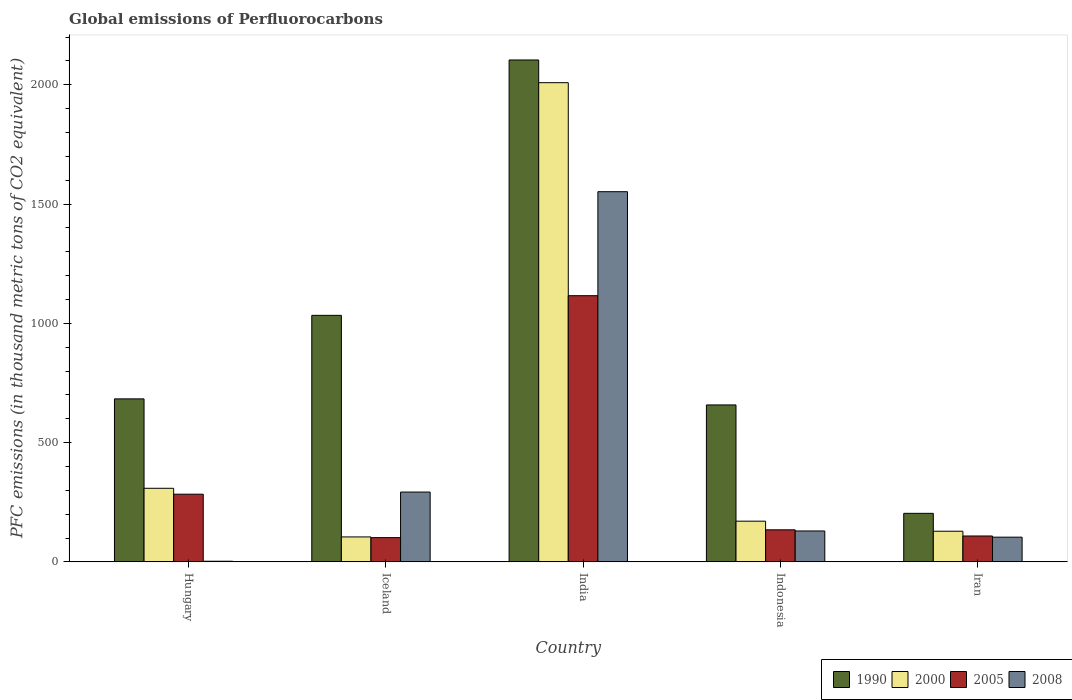How many different coloured bars are there?
Provide a succinct answer. 4. What is the global emissions of Perfluorocarbons in 2000 in Indonesia?
Your response must be concise. 170.6. Across all countries, what is the maximum global emissions of Perfluorocarbons in 1990?
Provide a succinct answer. 2104. In which country was the global emissions of Perfluorocarbons in 2008 minimum?
Offer a terse response. Hungary. What is the total global emissions of Perfluorocarbons in 2000 in the graph?
Offer a terse response. 2721. What is the difference between the global emissions of Perfluorocarbons in 2000 in India and that in Indonesia?
Give a very brief answer. 1838.2. What is the difference between the global emissions of Perfluorocarbons in 2000 in Iran and the global emissions of Perfluorocarbons in 2008 in Hungary?
Keep it short and to the point. 125.8. What is the average global emissions of Perfluorocarbons in 2008 per country?
Your answer should be compact. 416.08. What is the ratio of the global emissions of Perfluorocarbons in 2008 in India to that in Iran?
Keep it short and to the point. 14.98. Is the difference between the global emissions of Perfluorocarbons in 2005 in India and Iran greater than the difference between the global emissions of Perfluorocarbons in 2000 in India and Iran?
Provide a succinct answer. No. What is the difference between the highest and the second highest global emissions of Perfluorocarbons in 2000?
Offer a very short reply. 1838.2. What is the difference between the highest and the lowest global emissions of Perfluorocarbons in 2008?
Your response must be concise. 1549.1. Is the sum of the global emissions of Perfluorocarbons in 2008 in India and Iran greater than the maximum global emissions of Perfluorocarbons in 1990 across all countries?
Give a very brief answer. No. What does the 4th bar from the left in Iceland represents?
Your answer should be very brief. 2008. What does the 2nd bar from the right in Iceland represents?
Make the answer very short. 2005. How many bars are there?
Make the answer very short. 20. Are the values on the major ticks of Y-axis written in scientific E-notation?
Keep it short and to the point. No. Does the graph contain any zero values?
Make the answer very short. No. Does the graph contain grids?
Your response must be concise. No. Where does the legend appear in the graph?
Offer a terse response. Bottom right. What is the title of the graph?
Offer a terse response. Global emissions of Perfluorocarbons. What is the label or title of the Y-axis?
Offer a very short reply. PFC emissions (in thousand metric tons of CO2 equivalent). What is the PFC emissions (in thousand metric tons of CO2 equivalent) of 1990 in Hungary?
Ensure brevity in your answer.  683.3. What is the PFC emissions (in thousand metric tons of CO2 equivalent) of 2000 in Hungary?
Give a very brief answer. 308.5. What is the PFC emissions (in thousand metric tons of CO2 equivalent) of 2005 in Hungary?
Your answer should be compact. 283.7. What is the PFC emissions (in thousand metric tons of CO2 equivalent) of 2008 in Hungary?
Provide a short and direct response. 2.7. What is the PFC emissions (in thousand metric tons of CO2 equivalent) of 1990 in Iceland?
Provide a short and direct response. 1033.4. What is the PFC emissions (in thousand metric tons of CO2 equivalent) in 2000 in Iceland?
Keep it short and to the point. 104.6. What is the PFC emissions (in thousand metric tons of CO2 equivalent) of 2005 in Iceland?
Make the answer very short. 101.6. What is the PFC emissions (in thousand metric tons of CO2 equivalent) of 2008 in Iceland?
Offer a terse response. 292.7. What is the PFC emissions (in thousand metric tons of CO2 equivalent) of 1990 in India?
Your answer should be compact. 2104. What is the PFC emissions (in thousand metric tons of CO2 equivalent) in 2000 in India?
Your answer should be compact. 2008.8. What is the PFC emissions (in thousand metric tons of CO2 equivalent) of 2005 in India?
Your answer should be very brief. 1115.8. What is the PFC emissions (in thousand metric tons of CO2 equivalent) in 2008 in India?
Ensure brevity in your answer.  1551.8. What is the PFC emissions (in thousand metric tons of CO2 equivalent) of 1990 in Indonesia?
Make the answer very short. 657.9. What is the PFC emissions (in thousand metric tons of CO2 equivalent) in 2000 in Indonesia?
Make the answer very short. 170.6. What is the PFC emissions (in thousand metric tons of CO2 equivalent) in 2005 in Indonesia?
Make the answer very short. 134.4. What is the PFC emissions (in thousand metric tons of CO2 equivalent) in 2008 in Indonesia?
Give a very brief answer. 129.6. What is the PFC emissions (in thousand metric tons of CO2 equivalent) in 1990 in Iran?
Your response must be concise. 203.5. What is the PFC emissions (in thousand metric tons of CO2 equivalent) in 2000 in Iran?
Keep it short and to the point. 128.5. What is the PFC emissions (in thousand metric tons of CO2 equivalent) in 2005 in Iran?
Offer a terse response. 108.5. What is the PFC emissions (in thousand metric tons of CO2 equivalent) in 2008 in Iran?
Give a very brief answer. 103.6. Across all countries, what is the maximum PFC emissions (in thousand metric tons of CO2 equivalent) of 1990?
Make the answer very short. 2104. Across all countries, what is the maximum PFC emissions (in thousand metric tons of CO2 equivalent) of 2000?
Your answer should be very brief. 2008.8. Across all countries, what is the maximum PFC emissions (in thousand metric tons of CO2 equivalent) in 2005?
Your answer should be compact. 1115.8. Across all countries, what is the maximum PFC emissions (in thousand metric tons of CO2 equivalent) of 2008?
Offer a terse response. 1551.8. Across all countries, what is the minimum PFC emissions (in thousand metric tons of CO2 equivalent) of 1990?
Make the answer very short. 203.5. Across all countries, what is the minimum PFC emissions (in thousand metric tons of CO2 equivalent) of 2000?
Keep it short and to the point. 104.6. Across all countries, what is the minimum PFC emissions (in thousand metric tons of CO2 equivalent) in 2005?
Your answer should be compact. 101.6. Across all countries, what is the minimum PFC emissions (in thousand metric tons of CO2 equivalent) in 2008?
Make the answer very short. 2.7. What is the total PFC emissions (in thousand metric tons of CO2 equivalent) of 1990 in the graph?
Offer a very short reply. 4682.1. What is the total PFC emissions (in thousand metric tons of CO2 equivalent) of 2000 in the graph?
Ensure brevity in your answer.  2721. What is the total PFC emissions (in thousand metric tons of CO2 equivalent) in 2005 in the graph?
Your answer should be compact. 1744. What is the total PFC emissions (in thousand metric tons of CO2 equivalent) of 2008 in the graph?
Give a very brief answer. 2080.4. What is the difference between the PFC emissions (in thousand metric tons of CO2 equivalent) of 1990 in Hungary and that in Iceland?
Keep it short and to the point. -350.1. What is the difference between the PFC emissions (in thousand metric tons of CO2 equivalent) in 2000 in Hungary and that in Iceland?
Offer a very short reply. 203.9. What is the difference between the PFC emissions (in thousand metric tons of CO2 equivalent) of 2005 in Hungary and that in Iceland?
Give a very brief answer. 182.1. What is the difference between the PFC emissions (in thousand metric tons of CO2 equivalent) of 2008 in Hungary and that in Iceland?
Make the answer very short. -290. What is the difference between the PFC emissions (in thousand metric tons of CO2 equivalent) in 1990 in Hungary and that in India?
Provide a short and direct response. -1420.7. What is the difference between the PFC emissions (in thousand metric tons of CO2 equivalent) in 2000 in Hungary and that in India?
Offer a terse response. -1700.3. What is the difference between the PFC emissions (in thousand metric tons of CO2 equivalent) in 2005 in Hungary and that in India?
Ensure brevity in your answer.  -832.1. What is the difference between the PFC emissions (in thousand metric tons of CO2 equivalent) in 2008 in Hungary and that in India?
Make the answer very short. -1549.1. What is the difference between the PFC emissions (in thousand metric tons of CO2 equivalent) of 1990 in Hungary and that in Indonesia?
Provide a succinct answer. 25.4. What is the difference between the PFC emissions (in thousand metric tons of CO2 equivalent) in 2000 in Hungary and that in Indonesia?
Your answer should be compact. 137.9. What is the difference between the PFC emissions (in thousand metric tons of CO2 equivalent) of 2005 in Hungary and that in Indonesia?
Ensure brevity in your answer.  149.3. What is the difference between the PFC emissions (in thousand metric tons of CO2 equivalent) in 2008 in Hungary and that in Indonesia?
Make the answer very short. -126.9. What is the difference between the PFC emissions (in thousand metric tons of CO2 equivalent) in 1990 in Hungary and that in Iran?
Keep it short and to the point. 479.8. What is the difference between the PFC emissions (in thousand metric tons of CO2 equivalent) in 2000 in Hungary and that in Iran?
Your answer should be very brief. 180. What is the difference between the PFC emissions (in thousand metric tons of CO2 equivalent) in 2005 in Hungary and that in Iran?
Offer a terse response. 175.2. What is the difference between the PFC emissions (in thousand metric tons of CO2 equivalent) in 2008 in Hungary and that in Iran?
Provide a short and direct response. -100.9. What is the difference between the PFC emissions (in thousand metric tons of CO2 equivalent) in 1990 in Iceland and that in India?
Your answer should be very brief. -1070.6. What is the difference between the PFC emissions (in thousand metric tons of CO2 equivalent) in 2000 in Iceland and that in India?
Your response must be concise. -1904.2. What is the difference between the PFC emissions (in thousand metric tons of CO2 equivalent) of 2005 in Iceland and that in India?
Ensure brevity in your answer.  -1014.2. What is the difference between the PFC emissions (in thousand metric tons of CO2 equivalent) in 2008 in Iceland and that in India?
Your response must be concise. -1259.1. What is the difference between the PFC emissions (in thousand metric tons of CO2 equivalent) in 1990 in Iceland and that in Indonesia?
Offer a terse response. 375.5. What is the difference between the PFC emissions (in thousand metric tons of CO2 equivalent) in 2000 in Iceland and that in Indonesia?
Provide a succinct answer. -66. What is the difference between the PFC emissions (in thousand metric tons of CO2 equivalent) of 2005 in Iceland and that in Indonesia?
Offer a terse response. -32.8. What is the difference between the PFC emissions (in thousand metric tons of CO2 equivalent) in 2008 in Iceland and that in Indonesia?
Provide a succinct answer. 163.1. What is the difference between the PFC emissions (in thousand metric tons of CO2 equivalent) of 1990 in Iceland and that in Iran?
Your answer should be very brief. 829.9. What is the difference between the PFC emissions (in thousand metric tons of CO2 equivalent) of 2000 in Iceland and that in Iran?
Your answer should be compact. -23.9. What is the difference between the PFC emissions (in thousand metric tons of CO2 equivalent) of 2008 in Iceland and that in Iran?
Provide a succinct answer. 189.1. What is the difference between the PFC emissions (in thousand metric tons of CO2 equivalent) of 1990 in India and that in Indonesia?
Keep it short and to the point. 1446.1. What is the difference between the PFC emissions (in thousand metric tons of CO2 equivalent) of 2000 in India and that in Indonesia?
Provide a succinct answer. 1838.2. What is the difference between the PFC emissions (in thousand metric tons of CO2 equivalent) in 2005 in India and that in Indonesia?
Your answer should be very brief. 981.4. What is the difference between the PFC emissions (in thousand metric tons of CO2 equivalent) in 2008 in India and that in Indonesia?
Make the answer very short. 1422.2. What is the difference between the PFC emissions (in thousand metric tons of CO2 equivalent) in 1990 in India and that in Iran?
Keep it short and to the point. 1900.5. What is the difference between the PFC emissions (in thousand metric tons of CO2 equivalent) in 2000 in India and that in Iran?
Provide a succinct answer. 1880.3. What is the difference between the PFC emissions (in thousand metric tons of CO2 equivalent) of 2005 in India and that in Iran?
Your answer should be very brief. 1007.3. What is the difference between the PFC emissions (in thousand metric tons of CO2 equivalent) of 2008 in India and that in Iran?
Your answer should be compact. 1448.2. What is the difference between the PFC emissions (in thousand metric tons of CO2 equivalent) in 1990 in Indonesia and that in Iran?
Provide a short and direct response. 454.4. What is the difference between the PFC emissions (in thousand metric tons of CO2 equivalent) in 2000 in Indonesia and that in Iran?
Your answer should be very brief. 42.1. What is the difference between the PFC emissions (in thousand metric tons of CO2 equivalent) in 2005 in Indonesia and that in Iran?
Your answer should be very brief. 25.9. What is the difference between the PFC emissions (in thousand metric tons of CO2 equivalent) in 1990 in Hungary and the PFC emissions (in thousand metric tons of CO2 equivalent) in 2000 in Iceland?
Provide a succinct answer. 578.7. What is the difference between the PFC emissions (in thousand metric tons of CO2 equivalent) of 1990 in Hungary and the PFC emissions (in thousand metric tons of CO2 equivalent) of 2005 in Iceland?
Provide a succinct answer. 581.7. What is the difference between the PFC emissions (in thousand metric tons of CO2 equivalent) of 1990 in Hungary and the PFC emissions (in thousand metric tons of CO2 equivalent) of 2008 in Iceland?
Offer a very short reply. 390.6. What is the difference between the PFC emissions (in thousand metric tons of CO2 equivalent) in 2000 in Hungary and the PFC emissions (in thousand metric tons of CO2 equivalent) in 2005 in Iceland?
Your answer should be compact. 206.9. What is the difference between the PFC emissions (in thousand metric tons of CO2 equivalent) of 2000 in Hungary and the PFC emissions (in thousand metric tons of CO2 equivalent) of 2008 in Iceland?
Offer a very short reply. 15.8. What is the difference between the PFC emissions (in thousand metric tons of CO2 equivalent) of 2005 in Hungary and the PFC emissions (in thousand metric tons of CO2 equivalent) of 2008 in Iceland?
Provide a succinct answer. -9. What is the difference between the PFC emissions (in thousand metric tons of CO2 equivalent) in 1990 in Hungary and the PFC emissions (in thousand metric tons of CO2 equivalent) in 2000 in India?
Provide a short and direct response. -1325.5. What is the difference between the PFC emissions (in thousand metric tons of CO2 equivalent) of 1990 in Hungary and the PFC emissions (in thousand metric tons of CO2 equivalent) of 2005 in India?
Provide a succinct answer. -432.5. What is the difference between the PFC emissions (in thousand metric tons of CO2 equivalent) in 1990 in Hungary and the PFC emissions (in thousand metric tons of CO2 equivalent) in 2008 in India?
Provide a short and direct response. -868.5. What is the difference between the PFC emissions (in thousand metric tons of CO2 equivalent) in 2000 in Hungary and the PFC emissions (in thousand metric tons of CO2 equivalent) in 2005 in India?
Your answer should be compact. -807.3. What is the difference between the PFC emissions (in thousand metric tons of CO2 equivalent) of 2000 in Hungary and the PFC emissions (in thousand metric tons of CO2 equivalent) of 2008 in India?
Your response must be concise. -1243.3. What is the difference between the PFC emissions (in thousand metric tons of CO2 equivalent) of 2005 in Hungary and the PFC emissions (in thousand metric tons of CO2 equivalent) of 2008 in India?
Your answer should be compact. -1268.1. What is the difference between the PFC emissions (in thousand metric tons of CO2 equivalent) in 1990 in Hungary and the PFC emissions (in thousand metric tons of CO2 equivalent) in 2000 in Indonesia?
Your response must be concise. 512.7. What is the difference between the PFC emissions (in thousand metric tons of CO2 equivalent) of 1990 in Hungary and the PFC emissions (in thousand metric tons of CO2 equivalent) of 2005 in Indonesia?
Provide a short and direct response. 548.9. What is the difference between the PFC emissions (in thousand metric tons of CO2 equivalent) of 1990 in Hungary and the PFC emissions (in thousand metric tons of CO2 equivalent) of 2008 in Indonesia?
Offer a terse response. 553.7. What is the difference between the PFC emissions (in thousand metric tons of CO2 equivalent) of 2000 in Hungary and the PFC emissions (in thousand metric tons of CO2 equivalent) of 2005 in Indonesia?
Offer a terse response. 174.1. What is the difference between the PFC emissions (in thousand metric tons of CO2 equivalent) in 2000 in Hungary and the PFC emissions (in thousand metric tons of CO2 equivalent) in 2008 in Indonesia?
Offer a terse response. 178.9. What is the difference between the PFC emissions (in thousand metric tons of CO2 equivalent) of 2005 in Hungary and the PFC emissions (in thousand metric tons of CO2 equivalent) of 2008 in Indonesia?
Provide a short and direct response. 154.1. What is the difference between the PFC emissions (in thousand metric tons of CO2 equivalent) of 1990 in Hungary and the PFC emissions (in thousand metric tons of CO2 equivalent) of 2000 in Iran?
Ensure brevity in your answer.  554.8. What is the difference between the PFC emissions (in thousand metric tons of CO2 equivalent) of 1990 in Hungary and the PFC emissions (in thousand metric tons of CO2 equivalent) of 2005 in Iran?
Offer a very short reply. 574.8. What is the difference between the PFC emissions (in thousand metric tons of CO2 equivalent) in 1990 in Hungary and the PFC emissions (in thousand metric tons of CO2 equivalent) in 2008 in Iran?
Make the answer very short. 579.7. What is the difference between the PFC emissions (in thousand metric tons of CO2 equivalent) in 2000 in Hungary and the PFC emissions (in thousand metric tons of CO2 equivalent) in 2005 in Iran?
Your response must be concise. 200. What is the difference between the PFC emissions (in thousand metric tons of CO2 equivalent) of 2000 in Hungary and the PFC emissions (in thousand metric tons of CO2 equivalent) of 2008 in Iran?
Provide a succinct answer. 204.9. What is the difference between the PFC emissions (in thousand metric tons of CO2 equivalent) of 2005 in Hungary and the PFC emissions (in thousand metric tons of CO2 equivalent) of 2008 in Iran?
Offer a very short reply. 180.1. What is the difference between the PFC emissions (in thousand metric tons of CO2 equivalent) of 1990 in Iceland and the PFC emissions (in thousand metric tons of CO2 equivalent) of 2000 in India?
Offer a very short reply. -975.4. What is the difference between the PFC emissions (in thousand metric tons of CO2 equivalent) of 1990 in Iceland and the PFC emissions (in thousand metric tons of CO2 equivalent) of 2005 in India?
Make the answer very short. -82.4. What is the difference between the PFC emissions (in thousand metric tons of CO2 equivalent) of 1990 in Iceland and the PFC emissions (in thousand metric tons of CO2 equivalent) of 2008 in India?
Provide a succinct answer. -518.4. What is the difference between the PFC emissions (in thousand metric tons of CO2 equivalent) in 2000 in Iceland and the PFC emissions (in thousand metric tons of CO2 equivalent) in 2005 in India?
Your answer should be compact. -1011.2. What is the difference between the PFC emissions (in thousand metric tons of CO2 equivalent) of 2000 in Iceland and the PFC emissions (in thousand metric tons of CO2 equivalent) of 2008 in India?
Offer a terse response. -1447.2. What is the difference between the PFC emissions (in thousand metric tons of CO2 equivalent) in 2005 in Iceland and the PFC emissions (in thousand metric tons of CO2 equivalent) in 2008 in India?
Your answer should be very brief. -1450.2. What is the difference between the PFC emissions (in thousand metric tons of CO2 equivalent) in 1990 in Iceland and the PFC emissions (in thousand metric tons of CO2 equivalent) in 2000 in Indonesia?
Ensure brevity in your answer.  862.8. What is the difference between the PFC emissions (in thousand metric tons of CO2 equivalent) of 1990 in Iceland and the PFC emissions (in thousand metric tons of CO2 equivalent) of 2005 in Indonesia?
Offer a very short reply. 899. What is the difference between the PFC emissions (in thousand metric tons of CO2 equivalent) in 1990 in Iceland and the PFC emissions (in thousand metric tons of CO2 equivalent) in 2008 in Indonesia?
Make the answer very short. 903.8. What is the difference between the PFC emissions (in thousand metric tons of CO2 equivalent) in 2000 in Iceland and the PFC emissions (in thousand metric tons of CO2 equivalent) in 2005 in Indonesia?
Keep it short and to the point. -29.8. What is the difference between the PFC emissions (in thousand metric tons of CO2 equivalent) in 2005 in Iceland and the PFC emissions (in thousand metric tons of CO2 equivalent) in 2008 in Indonesia?
Keep it short and to the point. -28. What is the difference between the PFC emissions (in thousand metric tons of CO2 equivalent) in 1990 in Iceland and the PFC emissions (in thousand metric tons of CO2 equivalent) in 2000 in Iran?
Your answer should be compact. 904.9. What is the difference between the PFC emissions (in thousand metric tons of CO2 equivalent) in 1990 in Iceland and the PFC emissions (in thousand metric tons of CO2 equivalent) in 2005 in Iran?
Provide a succinct answer. 924.9. What is the difference between the PFC emissions (in thousand metric tons of CO2 equivalent) of 1990 in Iceland and the PFC emissions (in thousand metric tons of CO2 equivalent) of 2008 in Iran?
Offer a very short reply. 929.8. What is the difference between the PFC emissions (in thousand metric tons of CO2 equivalent) of 2005 in Iceland and the PFC emissions (in thousand metric tons of CO2 equivalent) of 2008 in Iran?
Ensure brevity in your answer.  -2. What is the difference between the PFC emissions (in thousand metric tons of CO2 equivalent) in 1990 in India and the PFC emissions (in thousand metric tons of CO2 equivalent) in 2000 in Indonesia?
Provide a succinct answer. 1933.4. What is the difference between the PFC emissions (in thousand metric tons of CO2 equivalent) in 1990 in India and the PFC emissions (in thousand metric tons of CO2 equivalent) in 2005 in Indonesia?
Provide a short and direct response. 1969.6. What is the difference between the PFC emissions (in thousand metric tons of CO2 equivalent) of 1990 in India and the PFC emissions (in thousand metric tons of CO2 equivalent) of 2008 in Indonesia?
Provide a succinct answer. 1974.4. What is the difference between the PFC emissions (in thousand metric tons of CO2 equivalent) in 2000 in India and the PFC emissions (in thousand metric tons of CO2 equivalent) in 2005 in Indonesia?
Your answer should be compact. 1874.4. What is the difference between the PFC emissions (in thousand metric tons of CO2 equivalent) in 2000 in India and the PFC emissions (in thousand metric tons of CO2 equivalent) in 2008 in Indonesia?
Provide a short and direct response. 1879.2. What is the difference between the PFC emissions (in thousand metric tons of CO2 equivalent) in 2005 in India and the PFC emissions (in thousand metric tons of CO2 equivalent) in 2008 in Indonesia?
Ensure brevity in your answer.  986.2. What is the difference between the PFC emissions (in thousand metric tons of CO2 equivalent) in 1990 in India and the PFC emissions (in thousand metric tons of CO2 equivalent) in 2000 in Iran?
Ensure brevity in your answer.  1975.5. What is the difference between the PFC emissions (in thousand metric tons of CO2 equivalent) in 1990 in India and the PFC emissions (in thousand metric tons of CO2 equivalent) in 2005 in Iran?
Give a very brief answer. 1995.5. What is the difference between the PFC emissions (in thousand metric tons of CO2 equivalent) of 1990 in India and the PFC emissions (in thousand metric tons of CO2 equivalent) of 2008 in Iran?
Give a very brief answer. 2000.4. What is the difference between the PFC emissions (in thousand metric tons of CO2 equivalent) in 2000 in India and the PFC emissions (in thousand metric tons of CO2 equivalent) in 2005 in Iran?
Provide a short and direct response. 1900.3. What is the difference between the PFC emissions (in thousand metric tons of CO2 equivalent) in 2000 in India and the PFC emissions (in thousand metric tons of CO2 equivalent) in 2008 in Iran?
Keep it short and to the point. 1905.2. What is the difference between the PFC emissions (in thousand metric tons of CO2 equivalent) in 2005 in India and the PFC emissions (in thousand metric tons of CO2 equivalent) in 2008 in Iran?
Offer a terse response. 1012.2. What is the difference between the PFC emissions (in thousand metric tons of CO2 equivalent) in 1990 in Indonesia and the PFC emissions (in thousand metric tons of CO2 equivalent) in 2000 in Iran?
Provide a succinct answer. 529.4. What is the difference between the PFC emissions (in thousand metric tons of CO2 equivalent) in 1990 in Indonesia and the PFC emissions (in thousand metric tons of CO2 equivalent) in 2005 in Iran?
Give a very brief answer. 549.4. What is the difference between the PFC emissions (in thousand metric tons of CO2 equivalent) of 1990 in Indonesia and the PFC emissions (in thousand metric tons of CO2 equivalent) of 2008 in Iran?
Provide a succinct answer. 554.3. What is the difference between the PFC emissions (in thousand metric tons of CO2 equivalent) in 2000 in Indonesia and the PFC emissions (in thousand metric tons of CO2 equivalent) in 2005 in Iran?
Your answer should be compact. 62.1. What is the difference between the PFC emissions (in thousand metric tons of CO2 equivalent) in 2005 in Indonesia and the PFC emissions (in thousand metric tons of CO2 equivalent) in 2008 in Iran?
Make the answer very short. 30.8. What is the average PFC emissions (in thousand metric tons of CO2 equivalent) of 1990 per country?
Ensure brevity in your answer.  936.42. What is the average PFC emissions (in thousand metric tons of CO2 equivalent) of 2000 per country?
Ensure brevity in your answer.  544.2. What is the average PFC emissions (in thousand metric tons of CO2 equivalent) of 2005 per country?
Your response must be concise. 348.8. What is the average PFC emissions (in thousand metric tons of CO2 equivalent) in 2008 per country?
Ensure brevity in your answer.  416.08. What is the difference between the PFC emissions (in thousand metric tons of CO2 equivalent) of 1990 and PFC emissions (in thousand metric tons of CO2 equivalent) of 2000 in Hungary?
Keep it short and to the point. 374.8. What is the difference between the PFC emissions (in thousand metric tons of CO2 equivalent) in 1990 and PFC emissions (in thousand metric tons of CO2 equivalent) in 2005 in Hungary?
Your response must be concise. 399.6. What is the difference between the PFC emissions (in thousand metric tons of CO2 equivalent) of 1990 and PFC emissions (in thousand metric tons of CO2 equivalent) of 2008 in Hungary?
Your answer should be very brief. 680.6. What is the difference between the PFC emissions (in thousand metric tons of CO2 equivalent) of 2000 and PFC emissions (in thousand metric tons of CO2 equivalent) of 2005 in Hungary?
Give a very brief answer. 24.8. What is the difference between the PFC emissions (in thousand metric tons of CO2 equivalent) of 2000 and PFC emissions (in thousand metric tons of CO2 equivalent) of 2008 in Hungary?
Provide a short and direct response. 305.8. What is the difference between the PFC emissions (in thousand metric tons of CO2 equivalent) of 2005 and PFC emissions (in thousand metric tons of CO2 equivalent) of 2008 in Hungary?
Make the answer very short. 281. What is the difference between the PFC emissions (in thousand metric tons of CO2 equivalent) in 1990 and PFC emissions (in thousand metric tons of CO2 equivalent) in 2000 in Iceland?
Your answer should be compact. 928.8. What is the difference between the PFC emissions (in thousand metric tons of CO2 equivalent) in 1990 and PFC emissions (in thousand metric tons of CO2 equivalent) in 2005 in Iceland?
Keep it short and to the point. 931.8. What is the difference between the PFC emissions (in thousand metric tons of CO2 equivalent) in 1990 and PFC emissions (in thousand metric tons of CO2 equivalent) in 2008 in Iceland?
Offer a terse response. 740.7. What is the difference between the PFC emissions (in thousand metric tons of CO2 equivalent) of 2000 and PFC emissions (in thousand metric tons of CO2 equivalent) of 2005 in Iceland?
Give a very brief answer. 3. What is the difference between the PFC emissions (in thousand metric tons of CO2 equivalent) of 2000 and PFC emissions (in thousand metric tons of CO2 equivalent) of 2008 in Iceland?
Provide a succinct answer. -188.1. What is the difference between the PFC emissions (in thousand metric tons of CO2 equivalent) of 2005 and PFC emissions (in thousand metric tons of CO2 equivalent) of 2008 in Iceland?
Keep it short and to the point. -191.1. What is the difference between the PFC emissions (in thousand metric tons of CO2 equivalent) in 1990 and PFC emissions (in thousand metric tons of CO2 equivalent) in 2000 in India?
Give a very brief answer. 95.2. What is the difference between the PFC emissions (in thousand metric tons of CO2 equivalent) of 1990 and PFC emissions (in thousand metric tons of CO2 equivalent) of 2005 in India?
Give a very brief answer. 988.2. What is the difference between the PFC emissions (in thousand metric tons of CO2 equivalent) in 1990 and PFC emissions (in thousand metric tons of CO2 equivalent) in 2008 in India?
Your response must be concise. 552.2. What is the difference between the PFC emissions (in thousand metric tons of CO2 equivalent) in 2000 and PFC emissions (in thousand metric tons of CO2 equivalent) in 2005 in India?
Provide a succinct answer. 893. What is the difference between the PFC emissions (in thousand metric tons of CO2 equivalent) in 2000 and PFC emissions (in thousand metric tons of CO2 equivalent) in 2008 in India?
Give a very brief answer. 457. What is the difference between the PFC emissions (in thousand metric tons of CO2 equivalent) in 2005 and PFC emissions (in thousand metric tons of CO2 equivalent) in 2008 in India?
Make the answer very short. -436. What is the difference between the PFC emissions (in thousand metric tons of CO2 equivalent) in 1990 and PFC emissions (in thousand metric tons of CO2 equivalent) in 2000 in Indonesia?
Keep it short and to the point. 487.3. What is the difference between the PFC emissions (in thousand metric tons of CO2 equivalent) in 1990 and PFC emissions (in thousand metric tons of CO2 equivalent) in 2005 in Indonesia?
Your answer should be compact. 523.5. What is the difference between the PFC emissions (in thousand metric tons of CO2 equivalent) of 1990 and PFC emissions (in thousand metric tons of CO2 equivalent) of 2008 in Indonesia?
Your answer should be very brief. 528.3. What is the difference between the PFC emissions (in thousand metric tons of CO2 equivalent) of 2000 and PFC emissions (in thousand metric tons of CO2 equivalent) of 2005 in Indonesia?
Keep it short and to the point. 36.2. What is the difference between the PFC emissions (in thousand metric tons of CO2 equivalent) of 1990 and PFC emissions (in thousand metric tons of CO2 equivalent) of 2005 in Iran?
Provide a short and direct response. 95. What is the difference between the PFC emissions (in thousand metric tons of CO2 equivalent) in 1990 and PFC emissions (in thousand metric tons of CO2 equivalent) in 2008 in Iran?
Keep it short and to the point. 99.9. What is the difference between the PFC emissions (in thousand metric tons of CO2 equivalent) of 2000 and PFC emissions (in thousand metric tons of CO2 equivalent) of 2005 in Iran?
Offer a very short reply. 20. What is the difference between the PFC emissions (in thousand metric tons of CO2 equivalent) of 2000 and PFC emissions (in thousand metric tons of CO2 equivalent) of 2008 in Iran?
Offer a very short reply. 24.9. What is the difference between the PFC emissions (in thousand metric tons of CO2 equivalent) of 2005 and PFC emissions (in thousand metric tons of CO2 equivalent) of 2008 in Iran?
Provide a succinct answer. 4.9. What is the ratio of the PFC emissions (in thousand metric tons of CO2 equivalent) in 1990 in Hungary to that in Iceland?
Ensure brevity in your answer.  0.66. What is the ratio of the PFC emissions (in thousand metric tons of CO2 equivalent) of 2000 in Hungary to that in Iceland?
Offer a terse response. 2.95. What is the ratio of the PFC emissions (in thousand metric tons of CO2 equivalent) in 2005 in Hungary to that in Iceland?
Provide a short and direct response. 2.79. What is the ratio of the PFC emissions (in thousand metric tons of CO2 equivalent) in 2008 in Hungary to that in Iceland?
Make the answer very short. 0.01. What is the ratio of the PFC emissions (in thousand metric tons of CO2 equivalent) of 1990 in Hungary to that in India?
Give a very brief answer. 0.32. What is the ratio of the PFC emissions (in thousand metric tons of CO2 equivalent) of 2000 in Hungary to that in India?
Provide a succinct answer. 0.15. What is the ratio of the PFC emissions (in thousand metric tons of CO2 equivalent) of 2005 in Hungary to that in India?
Give a very brief answer. 0.25. What is the ratio of the PFC emissions (in thousand metric tons of CO2 equivalent) of 2008 in Hungary to that in India?
Offer a very short reply. 0. What is the ratio of the PFC emissions (in thousand metric tons of CO2 equivalent) in 1990 in Hungary to that in Indonesia?
Your answer should be compact. 1.04. What is the ratio of the PFC emissions (in thousand metric tons of CO2 equivalent) in 2000 in Hungary to that in Indonesia?
Provide a succinct answer. 1.81. What is the ratio of the PFC emissions (in thousand metric tons of CO2 equivalent) of 2005 in Hungary to that in Indonesia?
Offer a terse response. 2.11. What is the ratio of the PFC emissions (in thousand metric tons of CO2 equivalent) in 2008 in Hungary to that in Indonesia?
Your answer should be very brief. 0.02. What is the ratio of the PFC emissions (in thousand metric tons of CO2 equivalent) in 1990 in Hungary to that in Iran?
Your response must be concise. 3.36. What is the ratio of the PFC emissions (in thousand metric tons of CO2 equivalent) of 2000 in Hungary to that in Iran?
Give a very brief answer. 2.4. What is the ratio of the PFC emissions (in thousand metric tons of CO2 equivalent) in 2005 in Hungary to that in Iran?
Provide a succinct answer. 2.61. What is the ratio of the PFC emissions (in thousand metric tons of CO2 equivalent) of 2008 in Hungary to that in Iran?
Make the answer very short. 0.03. What is the ratio of the PFC emissions (in thousand metric tons of CO2 equivalent) of 1990 in Iceland to that in India?
Your answer should be compact. 0.49. What is the ratio of the PFC emissions (in thousand metric tons of CO2 equivalent) of 2000 in Iceland to that in India?
Provide a short and direct response. 0.05. What is the ratio of the PFC emissions (in thousand metric tons of CO2 equivalent) of 2005 in Iceland to that in India?
Offer a very short reply. 0.09. What is the ratio of the PFC emissions (in thousand metric tons of CO2 equivalent) in 2008 in Iceland to that in India?
Provide a succinct answer. 0.19. What is the ratio of the PFC emissions (in thousand metric tons of CO2 equivalent) of 1990 in Iceland to that in Indonesia?
Provide a succinct answer. 1.57. What is the ratio of the PFC emissions (in thousand metric tons of CO2 equivalent) in 2000 in Iceland to that in Indonesia?
Your response must be concise. 0.61. What is the ratio of the PFC emissions (in thousand metric tons of CO2 equivalent) in 2005 in Iceland to that in Indonesia?
Offer a very short reply. 0.76. What is the ratio of the PFC emissions (in thousand metric tons of CO2 equivalent) in 2008 in Iceland to that in Indonesia?
Make the answer very short. 2.26. What is the ratio of the PFC emissions (in thousand metric tons of CO2 equivalent) in 1990 in Iceland to that in Iran?
Your answer should be very brief. 5.08. What is the ratio of the PFC emissions (in thousand metric tons of CO2 equivalent) in 2000 in Iceland to that in Iran?
Offer a terse response. 0.81. What is the ratio of the PFC emissions (in thousand metric tons of CO2 equivalent) in 2005 in Iceland to that in Iran?
Your answer should be compact. 0.94. What is the ratio of the PFC emissions (in thousand metric tons of CO2 equivalent) in 2008 in Iceland to that in Iran?
Give a very brief answer. 2.83. What is the ratio of the PFC emissions (in thousand metric tons of CO2 equivalent) in 1990 in India to that in Indonesia?
Make the answer very short. 3.2. What is the ratio of the PFC emissions (in thousand metric tons of CO2 equivalent) of 2000 in India to that in Indonesia?
Offer a very short reply. 11.77. What is the ratio of the PFC emissions (in thousand metric tons of CO2 equivalent) of 2005 in India to that in Indonesia?
Your answer should be compact. 8.3. What is the ratio of the PFC emissions (in thousand metric tons of CO2 equivalent) in 2008 in India to that in Indonesia?
Give a very brief answer. 11.97. What is the ratio of the PFC emissions (in thousand metric tons of CO2 equivalent) in 1990 in India to that in Iran?
Offer a very short reply. 10.34. What is the ratio of the PFC emissions (in thousand metric tons of CO2 equivalent) in 2000 in India to that in Iran?
Your answer should be compact. 15.63. What is the ratio of the PFC emissions (in thousand metric tons of CO2 equivalent) in 2005 in India to that in Iran?
Your answer should be very brief. 10.28. What is the ratio of the PFC emissions (in thousand metric tons of CO2 equivalent) in 2008 in India to that in Iran?
Make the answer very short. 14.98. What is the ratio of the PFC emissions (in thousand metric tons of CO2 equivalent) of 1990 in Indonesia to that in Iran?
Ensure brevity in your answer.  3.23. What is the ratio of the PFC emissions (in thousand metric tons of CO2 equivalent) in 2000 in Indonesia to that in Iran?
Offer a terse response. 1.33. What is the ratio of the PFC emissions (in thousand metric tons of CO2 equivalent) in 2005 in Indonesia to that in Iran?
Your answer should be very brief. 1.24. What is the ratio of the PFC emissions (in thousand metric tons of CO2 equivalent) in 2008 in Indonesia to that in Iran?
Provide a succinct answer. 1.25. What is the difference between the highest and the second highest PFC emissions (in thousand metric tons of CO2 equivalent) of 1990?
Provide a succinct answer. 1070.6. What is the difference between the highest and the second highest PFC emissions (in thousand metric tons of CO2 equivalent) in 2000?
Offer a very short reply. 1700.3. What is the difference between the highest and the second highest PFC emissions (in thousand metric tons of CO2 equivalent) of 2005?
Keep it short and to the point. 832.1. What is the difference between the highest and the second highest PFC emissions (in thousand metric tons of CO2 equivalent) in 2008?
Make the answer very short. 1259.1. What is the difference between the highest and the lowest PFC emissions (in thousand metric tons of CO2 equivalent) of 1990?
Provide a succinct answer. 1900.5. What is the difference between the highest and the lowest PFC emissions (in thousand metric tons of CO2 equivalent) of 2000?
Your answer should be compact. 1904.2. What is the difference between the highest and the lowest PFC emissions (in thousand metric tons of CO2 equivalent) in 2005?
Provide a succinct answer. 1014.2. What is the difference between the highest and the lowest PFC emissions (in thousand metric tons of CO2 equivalent) of 2008?
Provide a short and direct response. 1549.1. 